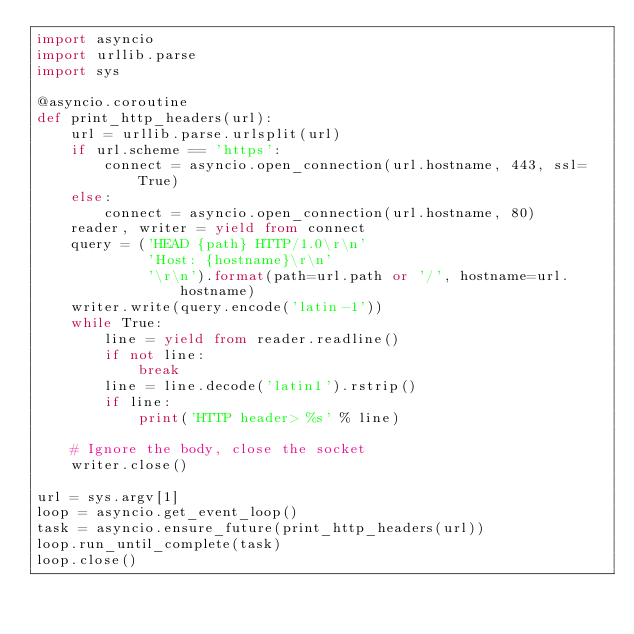<code> <loc_0><loc_0><loc_500><loc_500><_Python_>import asyncio
import urllib.parse
import sys

@asyncio.coroutine
def print_http_headers(url):
    url = urllib.parse.urlsplit(url)
    if url.scheme == 'https':
        connect = asyncio.open_connection(url.hostname, 443, ssl=True)
    else:
        connect = asyncio.open_connection(url.hostname, 80)
    reader, writer = yield from connect
    query = ('HEAD {path} HTTP/1.0\r\n'
             'Host: {hostname}\r\n'
             '\r\n').format(path=url.path or '/', hostname=url.hostname)
    writer.write(query.encode('latin-1'))
    while True:
        line = yield from reader.readline()
        if not line:
            break
        line = line.decode('latin1').rstrip()
        if line:
            print('HTTP header> %s' % line)

    # Ignore the body, close the socket
    writer.close()

url = sys.argv[1]
loop = asyncio.get_event_loop()
task = asyncio.ensure_future(print_http_headers(url))
loop.run_until_complete(task)
loop.close()

</code> 